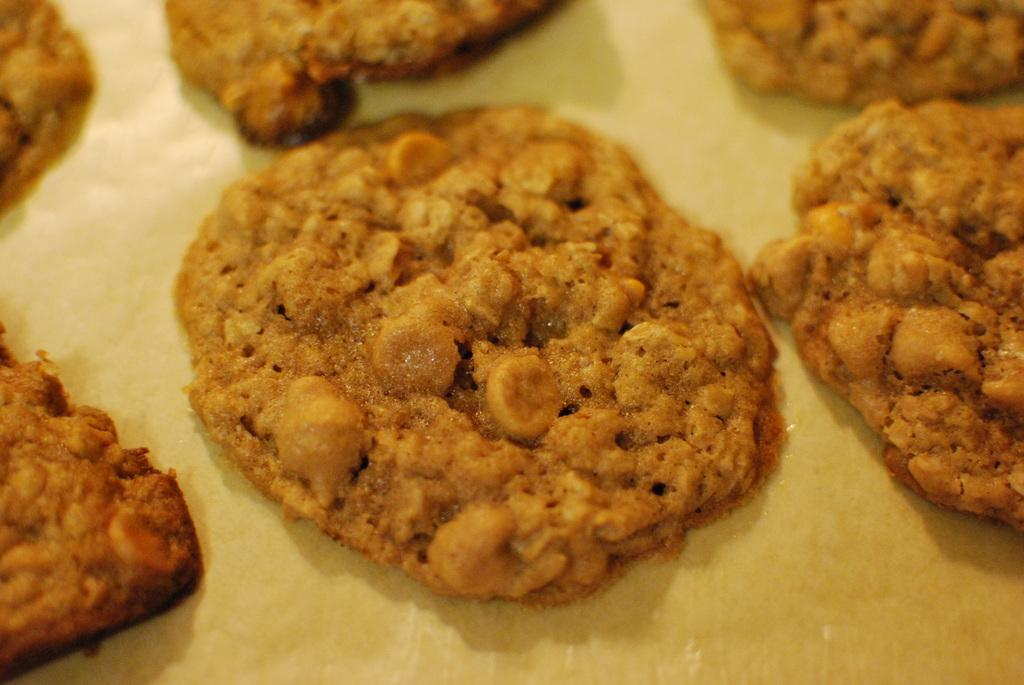What type of objects can be seen in the image? There are food items in the image. Where are the food items located? The food items are on a surface. Is there a rat visible in the image? No, there is no rat present in the image. 